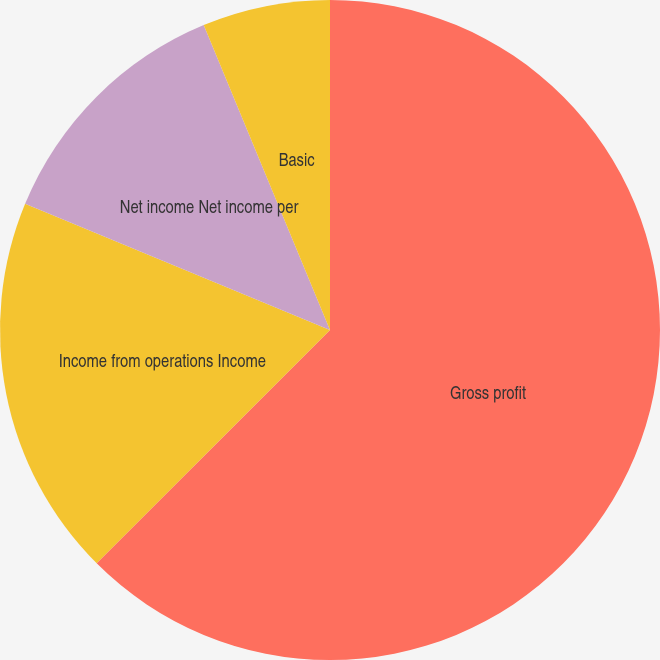<chart> <loc_0><loc_0><loc_500><loc_500><pie_chart><fcel>Gross profit<fcel>Income from operations Income<fcel>Net income Net income per<fcel>Basic<fcel>Diluted<nl><fcel>62.5%<fcel>18.75%<fcel>12.5%<fcel>6.25%<fcel>0.0%<nl></chart> 